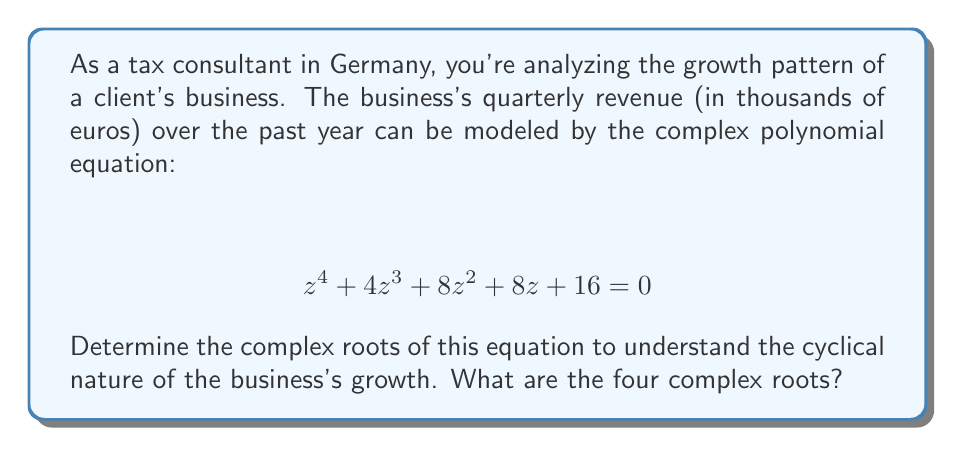Teach me how to tackle this problem. To solve this polynomial equation, we'll use the following steps:

1) First, notice that this is a fourth-degree polynomial equation. It's not immediately factorizable, so we'll need to use the rational root theorem and synthetic division.

2) The possible rational roots are the factors of the constant term (16): ±1, ±2, ±4, ±16.

3) Testing these values, we find that z = -2 is a root. Let's use synthetic division:

$$ \begin{array}{r}
   -2 | 1 \quad 4 \quad 8 \quad 8 \quad 16 \\
      | \quad -2 \quad -4 \quad -8 \quad -16 \\
   \hline
      1 \quad 2 \quad 4 \quad 0 \quad 0
\end{array} $$

4) This gives us: $(z + 2)(z^3 + 2z^2 + 4z + 8) = 0$

5) Now we need to solve $z^3 + 2z^2 + 4z + 8 = 0$

6) This cubic equation doesn't have any obvious rational roots, so we can use Cardano's formula or a computer algebra system. The roots are:

   $z = -2$
   $z = i\sqrt{2}$
   $z = -i\sqrt{2}$

7) Therefore, the four roots of the original equation are:

   $z_1 = -2$
   $z_2 = -2$
   $z_3 = i\sqrt{2}$
   $z_4 = -i\sqrt{2}$
Answer: The four complex roots are: $-2$ (double root), $i\sqrt{2}$, and $-i\sqrt{2}$. 